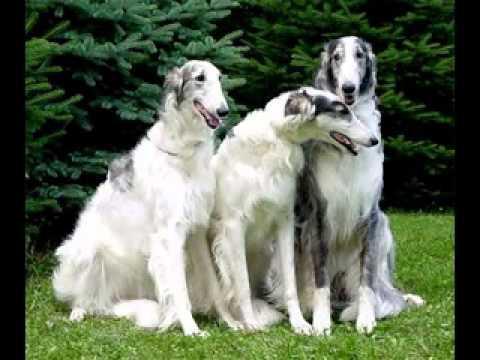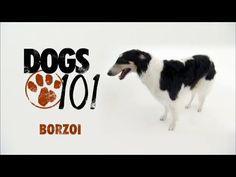The first image is the image on the left, the second image is the image on the right. Given the left and right images, does the statement "An image shows at least three hounds sitting upright in a row on green grass." hold true? Answer yes or no. Yes. The first image is the image on the left, the second image is the image on the right. Assess this claim about the two images: "There are four dogs in total.". Correct or not? Answer yes or no. Yes. 